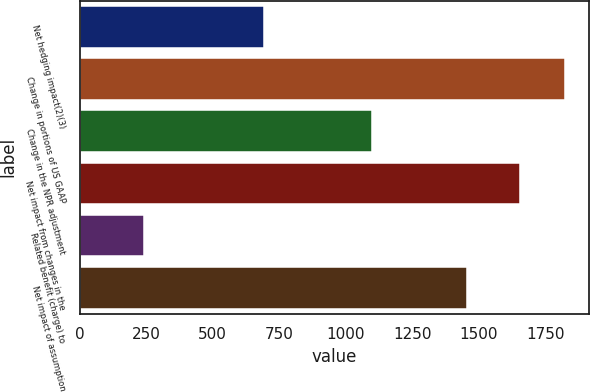Convert chart to OTSL. <chart><loc_0><loc_0><loc_500><loc_500><bar_chart><fcel>Net hedging impact(2)(3)<fcel>Change in portions of US GAAP<fcel>Change in the NPR adjustment<fcel>Net impact from changes in the<fcel>Related benefit (charge) to<fcel>Net impact of assumption<nl><fcel>692<fcel>1824.1<fcel>1097<fcel>1654<fcel>243<fcel>1455<nl></chart> 